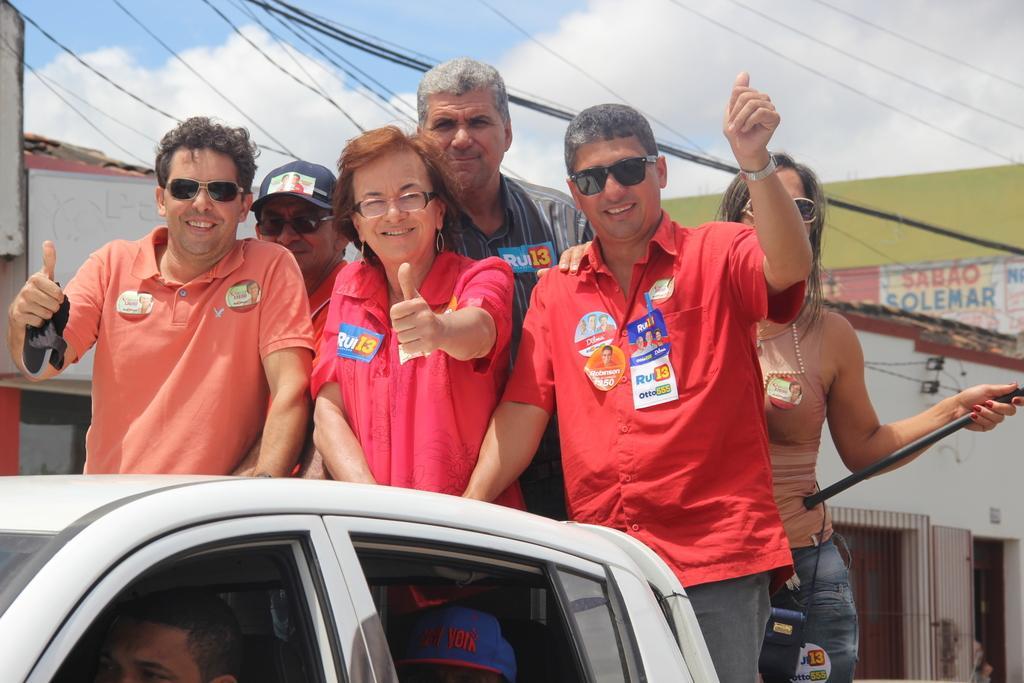Can you describe this image briefly? in the picture we can see a set of people standing in a car trolley, in the car we can also see some people in it, the people who are standing in the front row are wearing a red T-shirts, and the person who is standing behind is wearing a cap and one woman is also standing with them. in the background we can also see some wires, buildings , sky and clouds. 